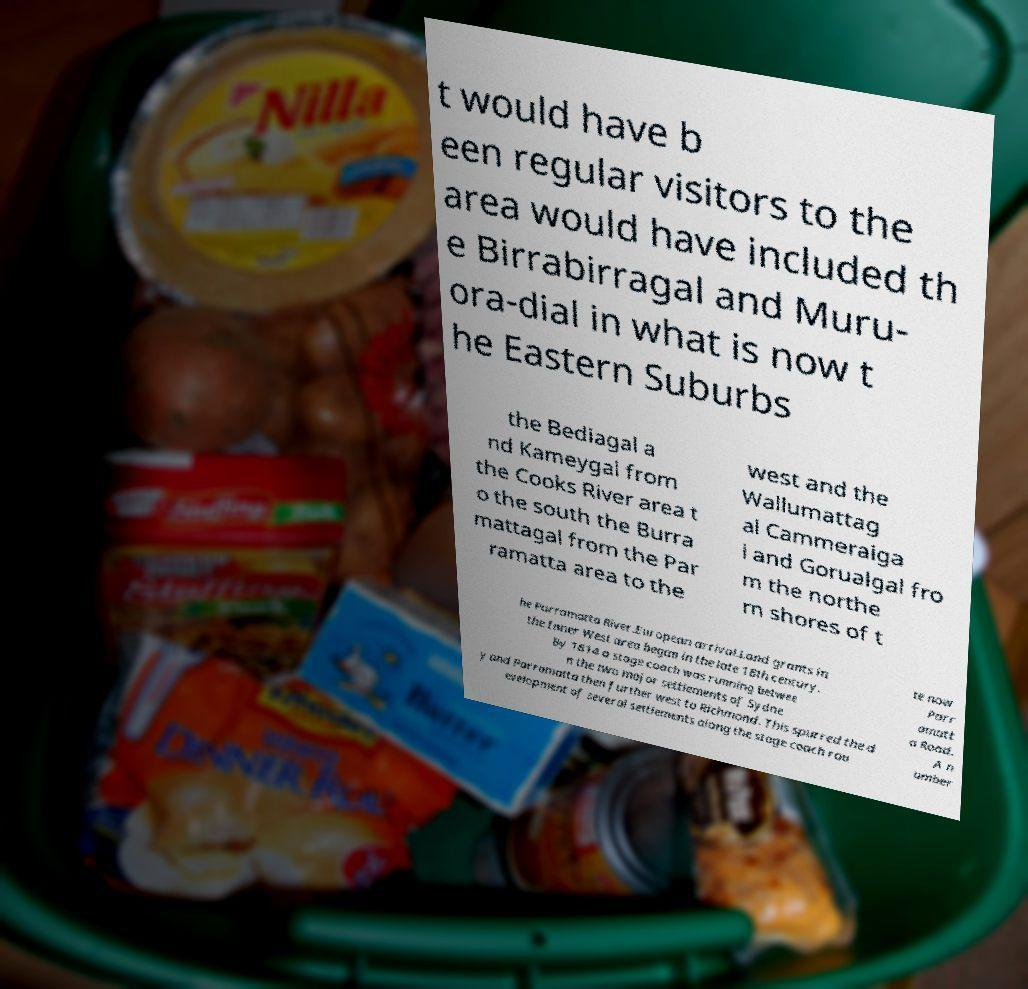Could you assist in decoding the text presented in this image and type it out clearly? t would have b een regular visitors to the area would have included th e Birrabirragal and Muru- ora-dial in what is now t he Eastern Suburbs the Bediagal a nd Kameygal from the Cooks River area t o the south the Burra mattagal from the Par ramatta area to the west and the Wallumattag al Cammeraiga l and Gorualgal fro m the northe rn shores of t he Parramatta River.European arrival.Land grants in the Inner West area began in the late 18th century. By 1814 a stage coach was running betwee n the two major settlements of Sydne y and Parramatta then further west to Richmond. This spurred the d evelopment of several settlements along the stage coach rou te now Parr amatt a Road. A n umber 